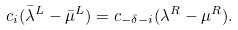Convert formula to latex. <formula><loc_0><loc_0><loc_500><loc_500>c _ { i } ( \bar { \lambda } ^ { L } - \bar { \mu } ^ { L } ) = c _ { - \delta - i } ( \lambda ^ { R } - \mu ^ { R } ) .</formula> 